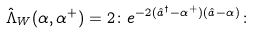<formula> <loc_0><loc_0><loc_500><loc_500>\hat { \Lambda } _ { W } ( \alpha , \alpha ^ { + } ) = 2 \colon e ^ { - 2 ( \hat { a } ^ { \dagger } - \alpha ^ { + } ) ( \hat { a } - \alpha ) } \colon</formula> 